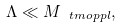Convert formula to latex. <formula><loc_0><loc_0><loc_500><loc_500>\Lambda \ll M _ { \ t m o p { p l } } ,</formula> 